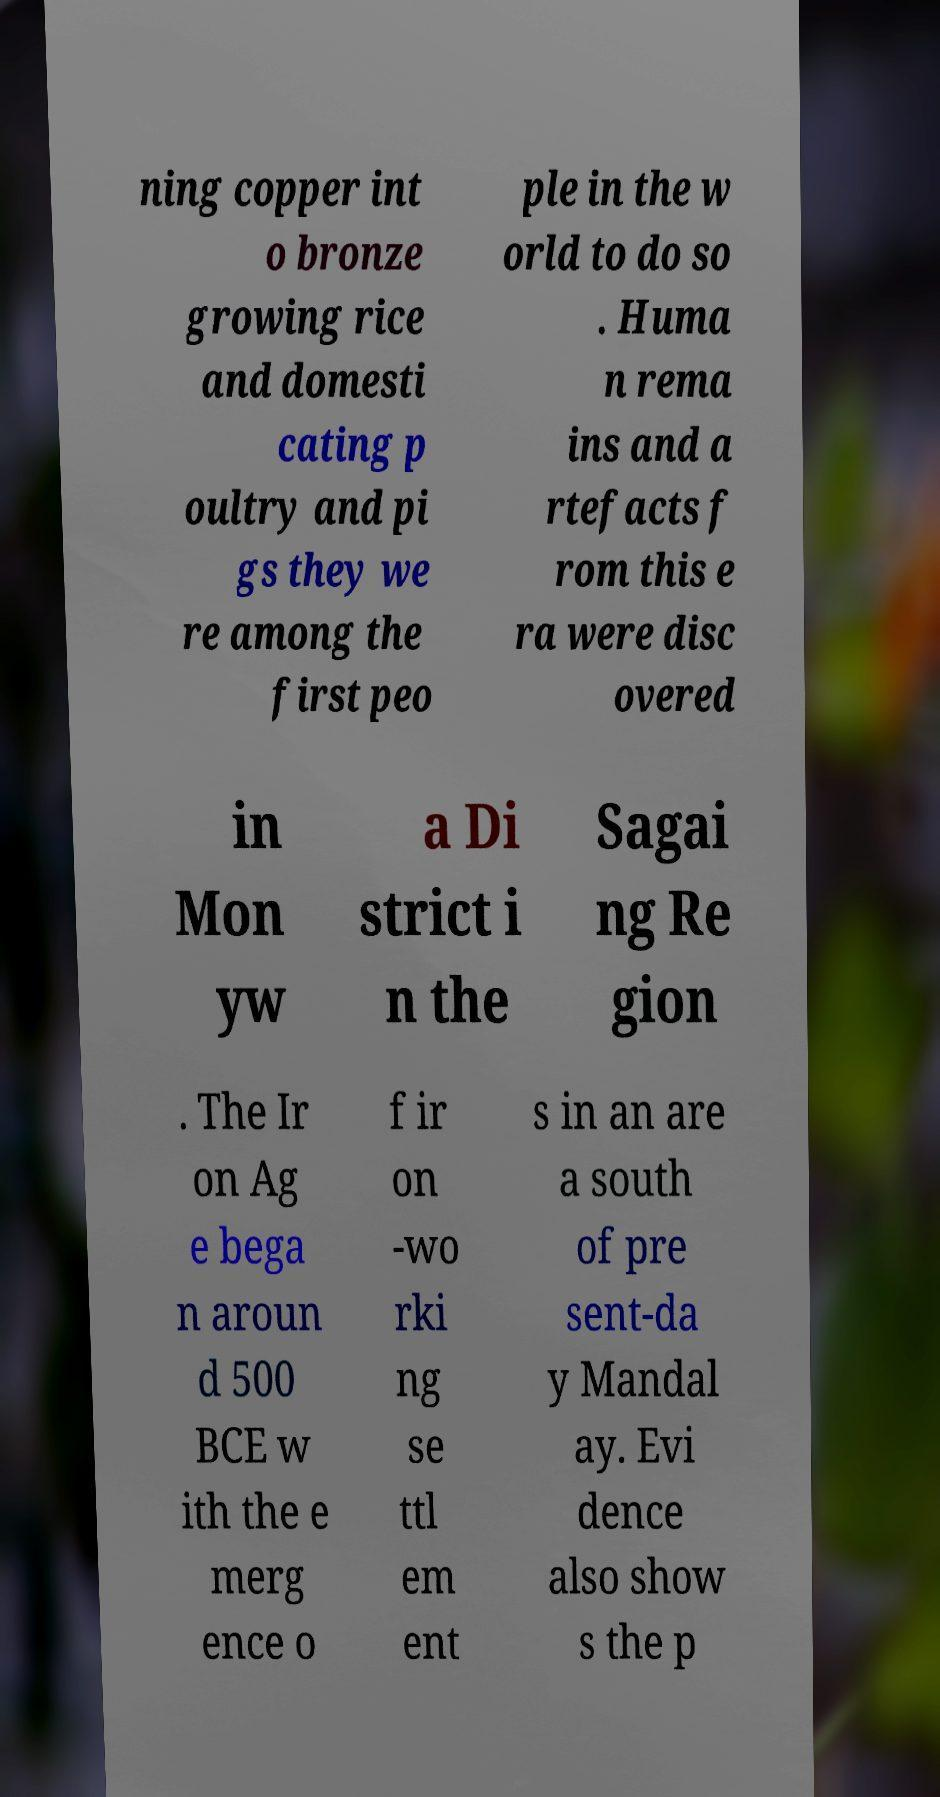Can you accurately transcribe the text from the provided image for me? ning copper int o bronze growing rice and domesti cating p oultry and pi gs they we re among the first peo ple in the w orld to do so . Huma n rema ins and a rtefacts f rom this e ra were disc overed in Mon yw a Di strict i n the Sagai ng Re gion . The Ir on Ag e bega n aroun d 500 BCE w ith the e merg ence o f ir on -wo rki ng se ttl em ent s in an are a south of pre sent-da y Mandal ay. Evi dence also show s the p 